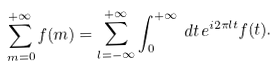Convert formula to latex. <formula><loc_0><loc_0><loc_500><loc_500>\sum _ { m = 0 } ^ { + \infty } f ( m ) = \sum _ { l = - \infty } ^ { + \infty } \int _ { 0 } ^ { + \infty } \, d t \, e ^ { i 2 \pi l t } f ( t ) .</formula> 